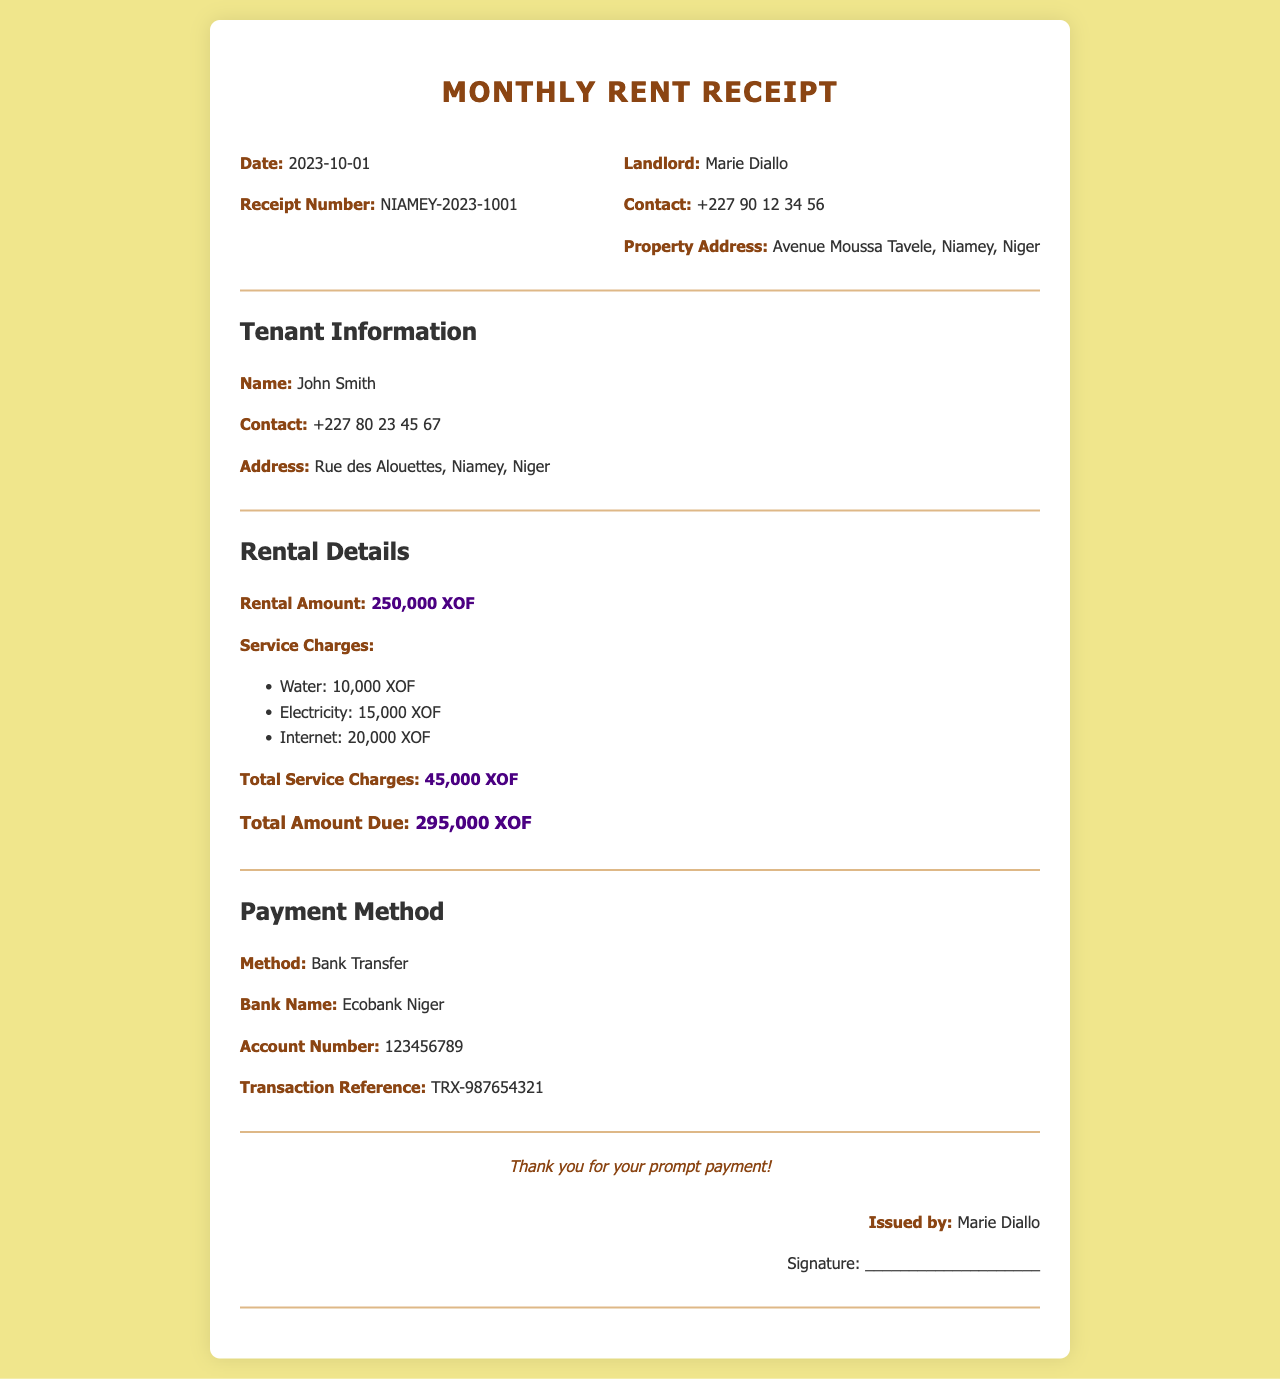What is the rental amount? The rental amount is listed under the rental details section as 250,000 XOF.
Answer: 250,000 XOF Who is the landlord? The landlord's name is mentioned in the header section of the document as Marie Diallo.
Answer: Marie Diallo What is the total amount due? The total amount due is calculated by adding the rental amount and total service charges, which is specified as 295,000 XOF.
Answer: 295,000 XOF What are the service charges for electricity? The service charges for electricity are listed as 15,000 XOF under the rental details section.
Answer: 15,000 XOF What payment method was used? The payment method is described in the payment method section and is specified as Bank Transfer.
Answer: Bank Transfer How many service charges are listed? There are three service charges listed: water, electricity, and internet.
Answer: Three What is the account number? The account number for the bank transfer is provided in the payment method section as 123456789.
Answer: 123456789 What is the transaction reference? The transaction reference is listed in the payment method section as TRX-987654321.
Answer: TRX-987654321 What is the date of the receipt? The date of the receipt is mentioned at the top in the header section as 2023-10-01.
Answer: 2023-10-01 